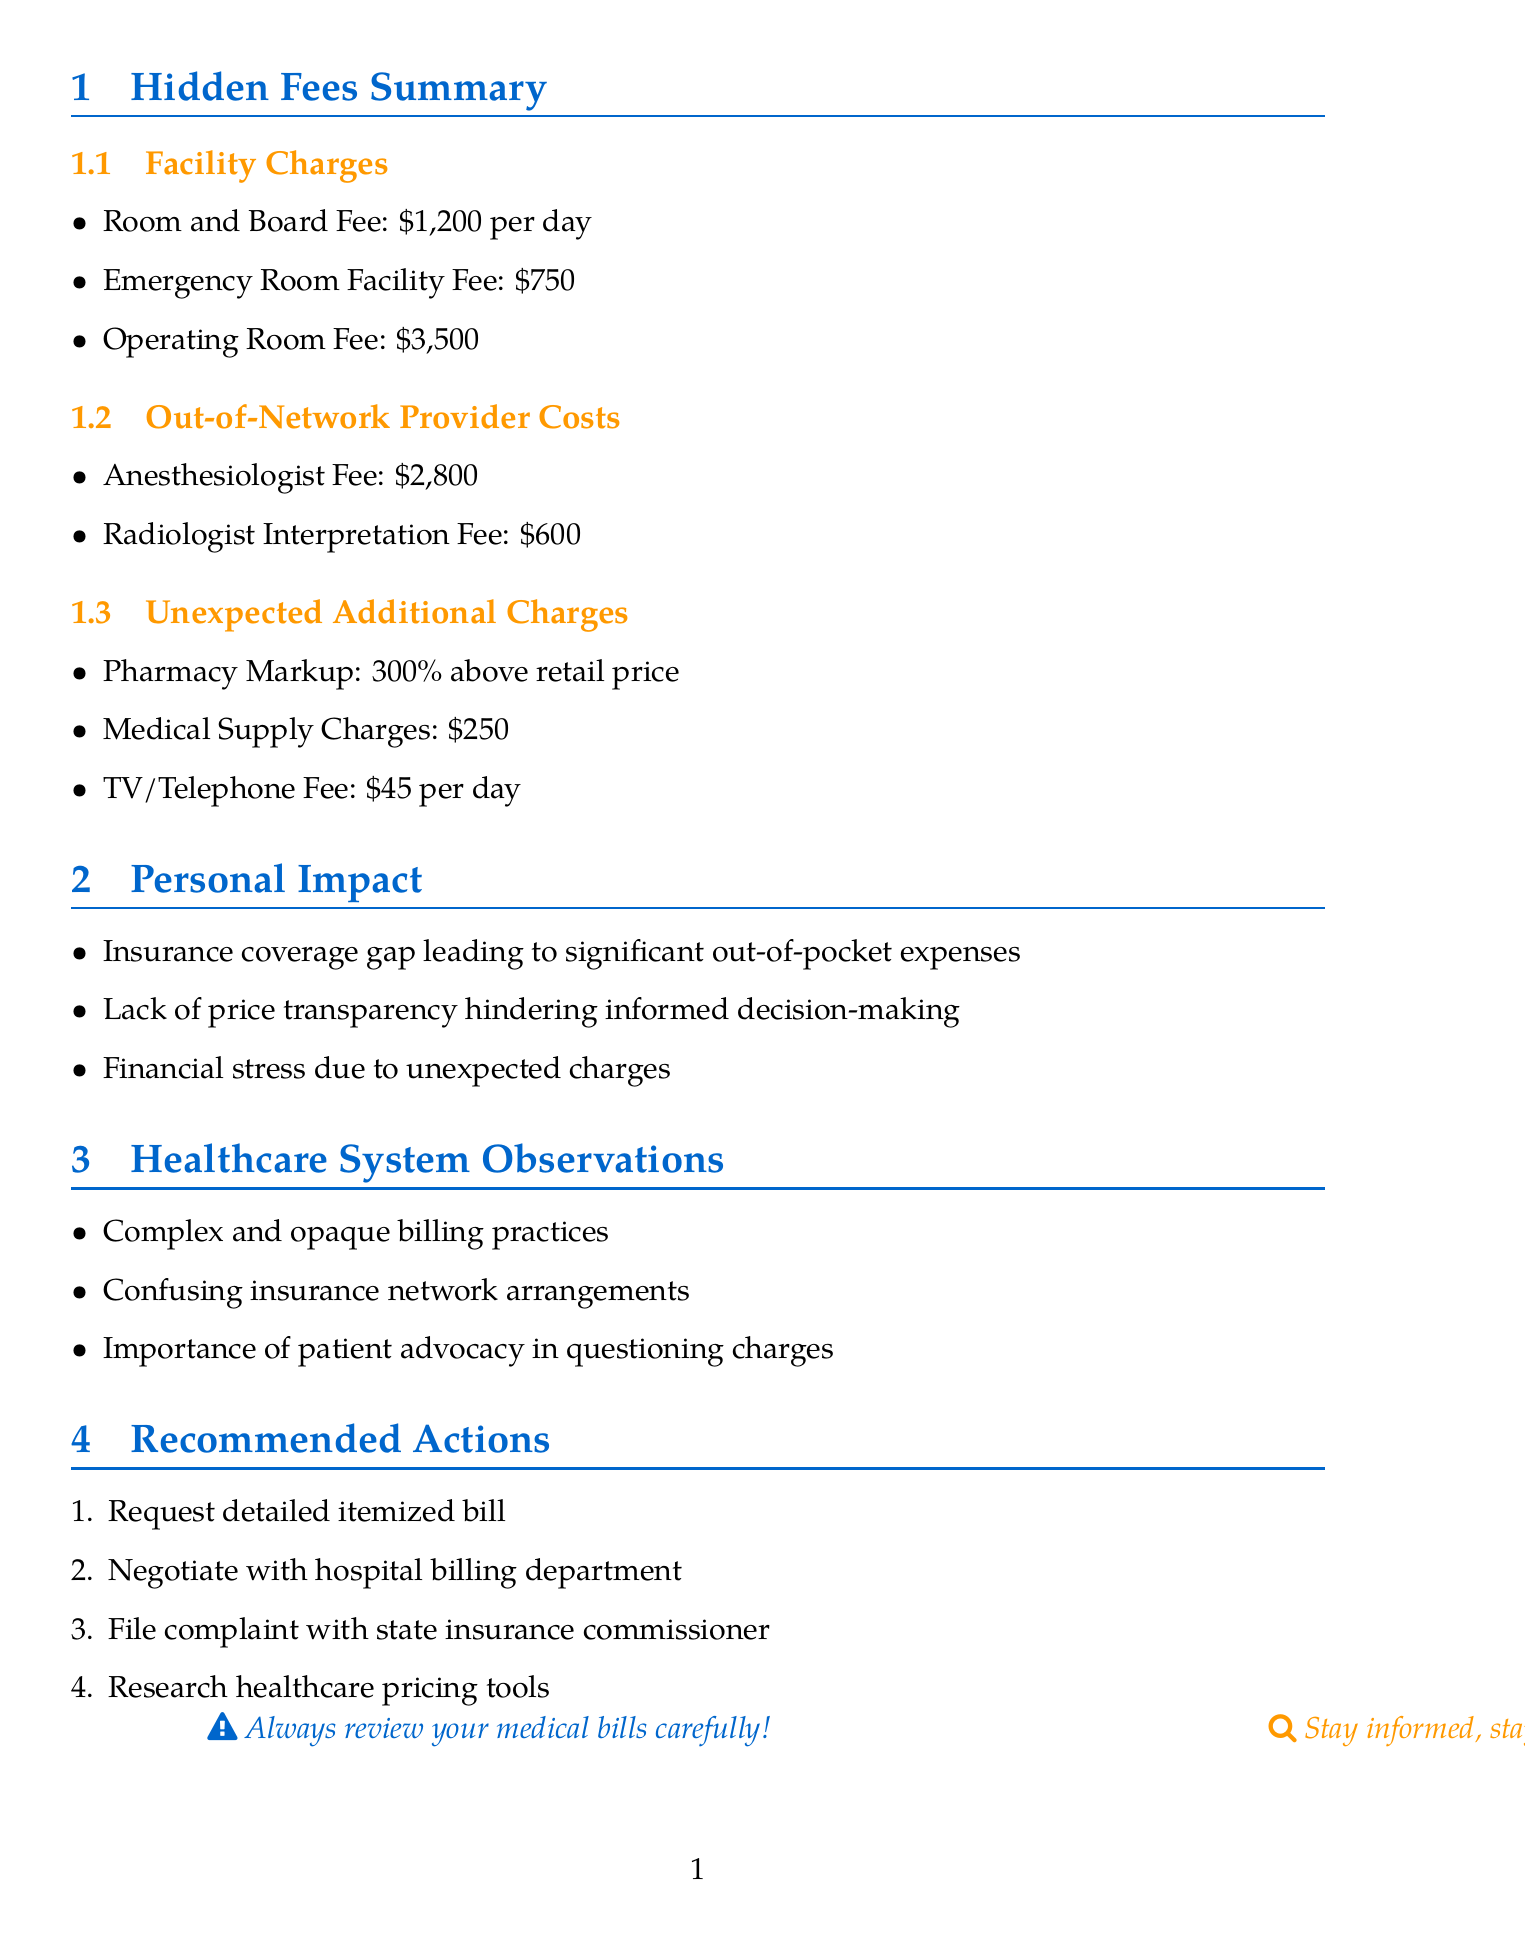What is the daily rate for the Room and Board Fee? The Room and Board Fee is listed in the Facility Charges section, which states it is unexpectedly high at $1,200 per day.
Answer: $1,200 per day What is the total amount for the Emergency Room Facility Fee? The Emergency Room Facility Fee is specified under Facility Charges, amounting to a separate charge of $750.
Answer: $750 How much does the Out-of-Network Anesthesiologist cost? The document provides the Anesthesiologist Fee under Out-of-Network Provider Costs at $2,800.
Answer: $2,800 What percentage above retail price is the Pharmacy Markup? The Pharmacy Markup is noted as inflated prices during the hospital stay, specifically 300% above retail price.
Answer: 300% What issue leads to significant out-of-pocket expenses despite having insurance? The document notes that the insurance coverage gap is the issue leading to significant out-of-pocket expenses.
Answer: Insurance coverage gap What is one recommended action to address unexpected out-of-network charges? One recommended action provided in the document is to file a complaint with the state insurance commissioner regarding unexpected charges.
Answer: File complaint How are hospital billing practices described in the document? The document comments on billing practices as complex and often opaque, making it difficult for patients to understand true costs.
Answer: Complex and opaque What type of fee is charged for TV and Telephone services? The fee for in-room entertainment and communication devices is specifically indicated as a separate charge under Unexpected Additional Charges.
Answer: $45 per day What is the purpose of negotiating with the hospital billing department? The purpose of negotiating with the hospital billing department is to potentially reduce charges or set up a manageable payment plan.
Answer: To potentially reduce charges 